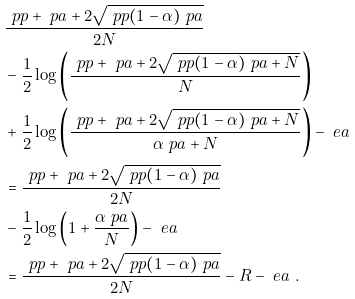Convert formula to latex. <formula><loc_0><loc_0><loc_500><loc_500>& \frac { \ p p + \ p a + 2 \sqrt { \ p p ( 1 - \alpha ) \ p a } } { 2 N } \\ & - \frac { 1 } { 2 } \log \left ( \frac { \ p p + \ p a + 2 \sqrt { \ p p ( 1 - \alpha ) \ p a + N } } { N } \right ) \\ & + \frac { 1 } { 2 } \log \left ( \frac { \ p p + \ p a + 2 \sqrt { \ p p ( 1 - \alpha ) \ p a + N } } { \alpha \ p a + N } \right ) - \ e a \\ & = \frac { \ p p + \ p a + 2 \sqrt { \ p p ( 1 - \alpha ) \ p a } } { 2 N } \\ & - \frac { 1 } { 2 } \log \left ( 1 + \frac { \alpha \ p a } { N } \right ) - \ e a \\ & = \frac { \ p p + \ p a + 2 \sqrt { \ p p ( 1 - \alpha ) \ p a } } { 2 N } - R - \ e a \ .</formula> 